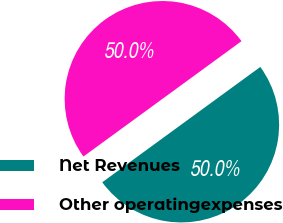<chart> <loc_0><loc_0><loc_500><loc_500><pie_chart><fcel>Net Revenues<fcel>Other operatingexpenses<nl><fcel>50.0%<fcel>50.0%<nl></chart> 